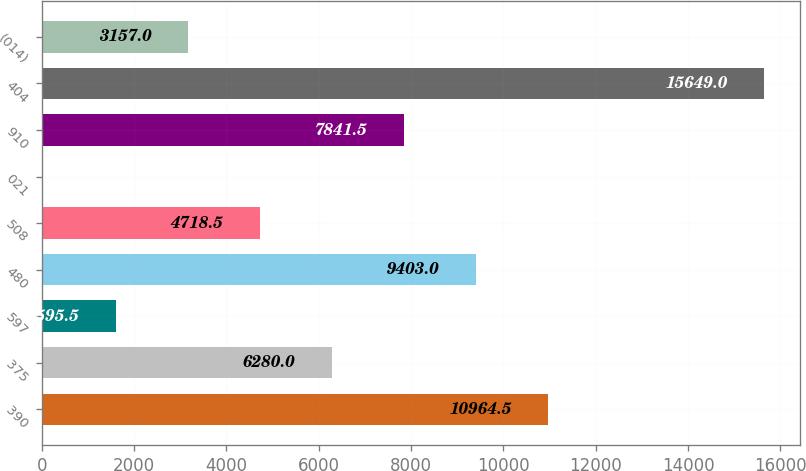Convert chart to OTSL. <chart><loc_0><loc_0><loc_500><loc_500><bar_chart><fcel>390<fcel>375<fcel>597<fcel>480<fcel>508<fcel>021<fcel>910<fcel>404<fcel>(014)<nl><fcel>10964.5<fcel>6280<fcel>1595.5<fcel>9403<fcel>4718.5<fcel>34<fcel>7841.5<fcel>15649<fcel>3157<nl></chart> 